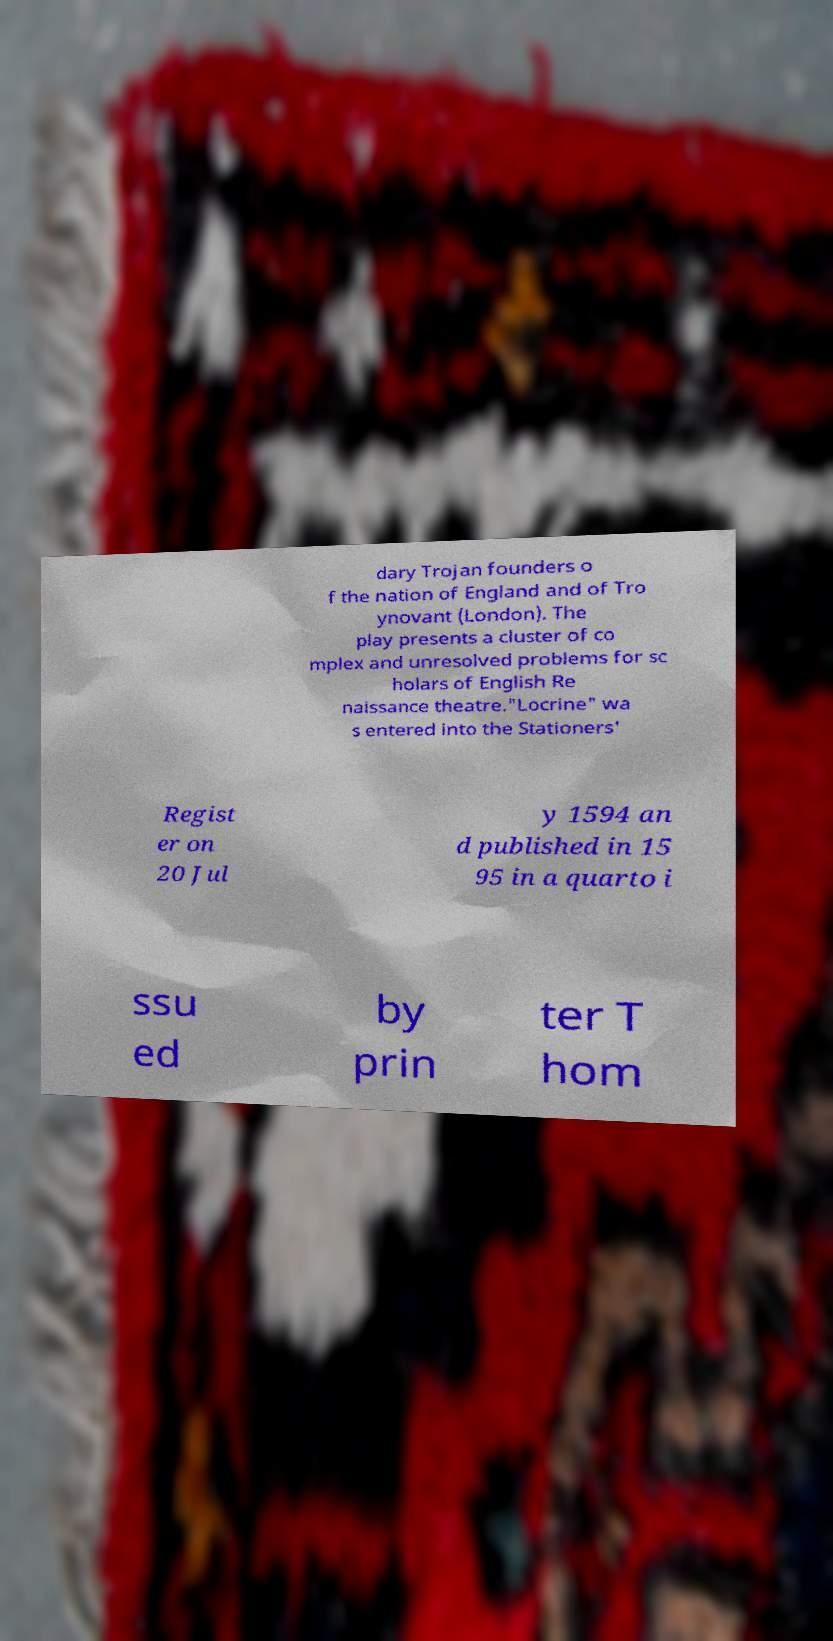Could you extract and type out the text from this image? dary Trojan founders o f the nation of England and of Tro ynovant (London). The play presents a cluster of co mplex and unresolved problems for sc holars of English Re naissance theatre."Locrine" wa s entered into the Stationers' Regist er on 20 Jul y 1594 an d published in 15 95 in a quarto i ssu ed by prin ter T hom 